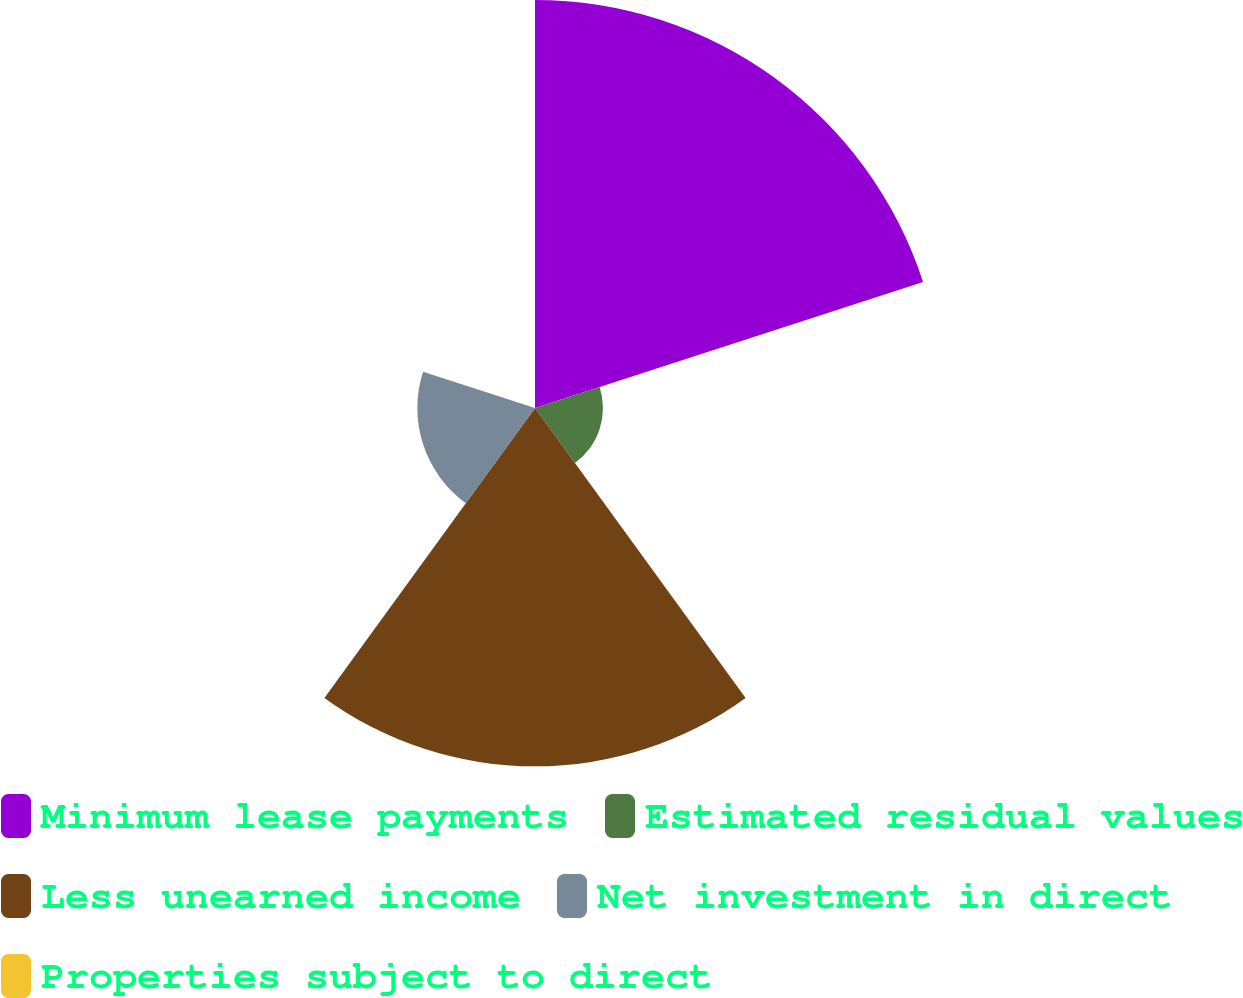<chart> <loc_0><loc_0><loc_500><loc_500><pie_chart><fcel>Minimum lease payments<fcel>Estimated residual values<fcel>Less unearned income<fcel>Net investment in direct<fcel>Properties subject to direct<nl><fcel>42.86%<fcel>7.14%<fcel>37.64%<fcel>12.36%<fcel>0.0%<nl></chart> 